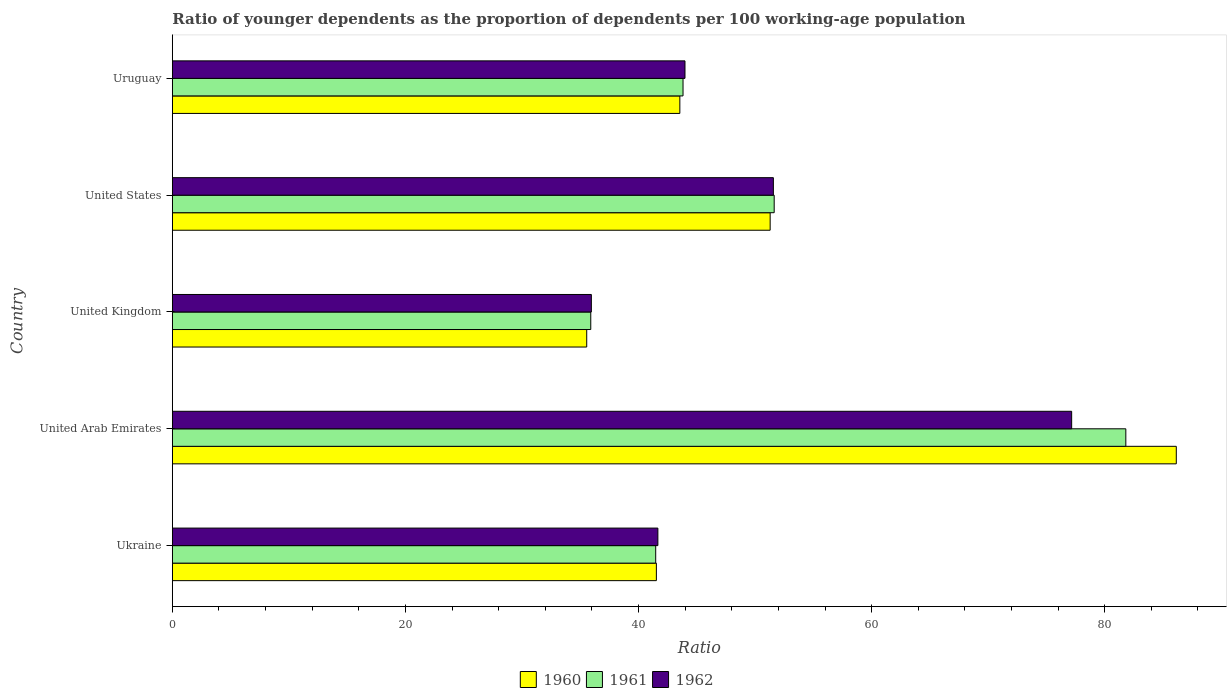How many different coloured bars are there?
Provide a succinct answer. 3. How many groups of bars are there?
Give a very brief answer. 5. Are the number of bars on each tick of the Y-axis equal?
Provide a short and direct response. Yes. How many bars are there on the 4th tick from the top?
Your response must be concise. 3. In how many cases, is the number of bars for a given country not equal to the number of legend labels?
Your answer should be compact. 0. What is the age dependency ratio(young) in 1962 in United States?
Ensure brevity in your answer.  51.57. Across all countries, what is the maximum age dependency ratio(young) in 1962?
Ensure brevity in your answer.  77.16. Across all countries, what is the minimum age dependency ratio(young) in 1962?
Ensure brevity in your answer.  35.95. In which country was the age dependency ratio(young) in 1962 maximum?
Provide a succinct answer. United Arab Emirates. In which country was the age dependency ratio(young) in 1960 minimum?
Make the answer very short. United Kingdom. What is the total age dependency ratio(young) in 1961 in the graph?
Give a very brief answer. 254.65. What is the difference between the age dependency ratio(young) in 1962 in United Kingdom and that in Uruguay?
Provide a succinct answer. -8.03. What is the difference between the age dependency ratio(young) in 1960 in United Kingdom and the age dependency ratio(young) in 1962 in Uruguay?
Provide a short and direct response. -8.43. What is the average age dependency ratio(young) in 1962 per country?
Provide a short and direct response. 50.07. What is the difference between the age dependency ratio(young) in 1961 and age dependency ratio(young) in 1960 in United Arab Emirates?
Your answer should be very brief. -4.33. What is the ratio of the age dependency ratio(young) in 1960 in Ukraine to that in United States?
Provide a short and direct response. 0.81. What is the difference between the highest and the second highest age dependency ratio(young) in 1961?
Make the answer very short. 30.17. What is the difference between the highest and the lowest age dependency ratio(young) in 1960?
Your answer should be compact. 50.59. In how many countries, is the age dependency ratio(young) in 1961 greater than the average age dependency ratio(young) in 1961 taken over all countries?
Make the answer very short. 2. Is the sum of the age dependency ratio(young) in 1961 in Ukraine and United Arab Emirates greater than the maximum age dependency ratio(young) in 1962 across all countries?
Keep it short and to the point. Yes. What does the 2nd bar from the top in United Arab Emirates represents?
Make the answer very short. 1961. Is it the case that in every country, the sum of the age dependency ratio(young) in 1962 and age dependency ratio(young) in 1961 is greater than the age dependency ratio(young) in 1960?
Your answer should be very brief. Yes. How many bars are there?
Ensure brevity in your answer.  15. Are the values on the major ticks of X-axis written in scientific E-notation?
Your answer should be compact. No. Does the graph contain any zero values?
Provide a short and direct response. No. Does the graph contain grids?
Make the answer very short. No. What is the title of the graph?
Offer a very short reply. Ratio of younger dependents as the proportion of dependents per 100 working-age population. What is the label or title of the X-axis?
Your response must be concise. Ratio. What is the Ratio of 1960 in Ukraine?
Ensure brevity in your answer.  41.53. What is the Ratio of 1961 in Ukraine?
Your answer should be compact. 41.47. What is the Ratio in 1962 in Ukraine?
Ensure brevity in your answer.  41.66. What is the Ratio in 1960 in United Arab Emirates?
Your answer should be very brief. 86.14. What is the Ratio in 1961 in United Arab Emirates?
Your answer should be compact. 81.81. What is the Ratio of 1962 in United Arab Emirates?
Make the answer very short. 77.16. What is the Ratio in 1960 in United Kingdom?
Your response must be concise. 35.55. What is the Ratio in 1961 in United Kingdom?
Make the answer very short. 35.9. What is the Ratio of 1962 in United Kingdom?
Your answer should be very brief. 35.95. What is the Ratio in 1960 in United States?
Provide a short and direct response. 51.29. What is the Ratio in 1961 in United States?
Your answer should be compact. 51.64. What is the Ratio in 1962 in United States?
Provide a short and direct response. 51.57. What is the Ratio in 1960 in Uruguay?
Provide a succinct answer. 43.54. What is the Ratio in 1961 in Uruguay?
Provide a short and direct response. 43.82. What is the Ratio in 1962 in Uruguay?
Provide a succinct answer. 43.99. Across all countries, what is the maximum Ratio of 1960?
Your answer should be compact. 86.14. Across all countries, what is the maximum Ratio of 1961?
Offer a terse response. 81.81. Across all countries, what is the maximum Ratio of 1962?
Give a very brief answer. 77.16. Across all countries, what is the minimum Ratio in 1960?
Provide a succinct answer. 35.55. Across all countries, what is the minimum Ratio of 1961?
Ensure brevity in your answer.  35.9. Across all countries, what is the minimum Ratio of 1962?
Provide a succinct answer. 35.95. What is the total Ratio in 1960 in the graph?
Offer a terse response. 258.07. What is the total Ratio of 1961 in the graph?
Your response must be concise. 254.65. What is the total Ratio of 1962 in the graph?
Give a very brief answer. 250.33. What is the difference between the Ratio in 1960 in Ukraine and that in United Arab Emirates?
Offer a terse response. -44.61. What is the difference between the Ratio in 1961 in Ukraine and that in United Arab Emirates?
Your answer should be very brief. -40.34. What is the difference between the Ratio of 1962 in Ukraine and that in United Arab Emirates?
Your answer should be compact. -35.5. What is the difference between the Ratio in 1960 in Ukraine and that in United Kingdom?
Offer a very short reply. 5.98. What is the difference between the Ratio in 1961 in Ukraine and that in United Kingdom?
Your answer should be compact. 5.57. What is the difference between the Ratio in 1962 in Ukraine and that in United Kingdom?
Make the answer very short. 5.71. What is the difference between the Ratio of 1960 in Ukraine and that in United States?
Provide a succinct answer. -9.76. What is the difference between the Ratio of 1961 in Ukraine and that in United States?
Provide a short and direct response. -10.17. What is the difference between the Ratio of 1962 in Ukraine and that in United States?
Give a very brief answer. -9.91. What is the difference between the Ratio of 1960 in Ukraine and that in Uruguay?
Offer a terse response. -2.01. What is the difference between the Ratio of 1961 in Ukraine and that in Uruguay?
Provide a succinct answer. -2.34. What is the difference between the Ratio of 1962 in Ukraine and that in Uruguay?
Make the answer very short. -2.33. What is the difference between the Ratio in 1960 in United Arab Emirates and that in United Kingdom?
Give a very brief answer. 50.59. What is the difference between the Ratio in 1961 in United Arab Emirates and that in United Kingdom?
Offer a very short reply. 45.91. What is the difference between the Ratio in 1962 in United Arab Emirates and that in United Kingdom?
Make the answer very short. 41.21. What is the difference between the Ratio of 1960 in United Arab Emirates and that in United States?
Ensure brevity in your answer.  34.85. What is the difference between the Ratio in 1961 in United Arab Emirates and that in United States?
Your answer should be compact. 30.17. What is the difference between the Ratio of 1962 in United Arab Emirates and that in United States?
Give a very brief answer. 25.59. What is the difference between the Ratio of 1960 in United Arab Emirates and that in Uruguay?
Your answer should be compact. 42.6. What is the difference between the Ratio in 1961 in United Arab Emirates and that in Uruguay?
Provide a short and direct response. 37.99. What is the difference between the Ratio of 1962 in United Arab Emirates and that in Uruguay?
Keep it short and to the point. 33.18. What is the difference between the Ratio in 1960 in United Kingdom and that in United States?
Ensure brevity in your answer.  -15.74. What is the difference between the Ratio in 1961 in United Kingdom and that in United States?
Provide a short and direct response. -15.74. What is the difference between the Ratio of 1962 in United Kingdom and that in United States?
Provide a short and direct response. -15.62. What is the difference between the Ratio of 1960 in United Kingdom and that in Uruguay?
Your answer should be compact. -7.99. What is the difference between the Ratio of 1961 in United Kingdom and that in Uruguay?
Your answer should be very brief. -7.92. What is the difference between the Ratio of 1962 in United Kingdom and that in Uruguay?
Your response must be concise. -8.03. What is the difference between the Ratio of 1960 in United States and that in Uruguay?
Provide a succinct answer. 7.75. What is the difference between the Ratio of 1961 in United States and that in Uruguay?
Offer a very short reply. 7.82. What is the difference between the Ratio in 1962 in United States and that in Uruguay?
Provide a succinct answer. 7.58. What is the difference between the Ratio of 1960 in Ukraine and the Ratio of 1961 in United Arab Emirates?
Provide a succinct answer. -40.28. What is the difference between the Ratio of 1960 in Ukraine and the Ratio of 1962 in United Arab Emirates?
Give a very brief answer. -35.63. What is the difference between the Ratio in 1961 in Ukraine and the Ratio in 1962 in United Arab Emirates?
Keep it short and to the point. -35.69. What is the difference between the Ratio in 1960 in Ukraine and the Ratio in 1961 in United Kingdom?
Your response must be concise. 5.63. What is the difference between the Ratio in 1960 in Ukraine and the Ratio in 1962 in United Kingdom?
Offer a terse response. 5.58. What is the difference between the Ratio of 1961 in Ukraine and the Ratio of 1962 in United Kingdom?
Give a very brief answer. 5.52. What is the difference between the Ratio of 1960 in Ukraine and the Ratio of 1961 in United States?
Make the answer very short. -10.11. What is the difference between the Ratio of 1960 in Ukraine and the Ratio of 1962 in United States?
Your response must be concise. -10.04. What is the difference between the Ratio of 1961 in Ukraine and the Ratio of 1962 in United States?
Provide a succinct answer. -10.1. What is the difference between the Ratio of 1960 in Ukraine and the Ratio of 1961 in Uruguay?
Provide a succinct answer. -2.29. What is the difference between the Ratio of 1960 in Ukraine and the Ratio of 1962 in Uruguay?
Ensure brevity in your answer.  -2.46. What is the difference between the Ratio in 1961 in Ukraine and the Ratio in 1962 in Uruguay?
Ensure brevity in your answer.  -2.51. What is the difference between the Ratio of 1960 in United Arab Emirates and the Ratio of 1961 in United Kingdom?
Keep it short and to the point. 50.24. What is the difference between the Ratio in 1960 in United Arab Emirates and the Ratio in 1962 in United Kingdom?
Provide a short and direct response. 50.19. What is the difference between the Ratio of 1961 in United Arab Emirates and the Ratio of 1962 in United Kingdom?
Ensure brevity in your answer.  45.86. What is the difference between the Ratio of 1960 in United Arab Emirates and the Ratio of 1961 in United States?
Provide a short and direct response. 34.5. What is the difference between the Ratio of 1960 in United Arab Emirates and the Ratio of 1962 in United States?
Make the answer very short. 34.57. What is the difference between the Ratio in 1961 in United Arab Emirates and the Ratio in 1962 in United States?
Your answer should be very brief. 30.24. What is the difference between the Ratio in 1960 in United Arab Emirates and the Ratio in 1961 in Uruguay?
Ensure brevity in your answer.  42.32. What is the difference between the Ratio of 1960 in United Arab Emirates and the Ratio of 1962 in Uruguay?
Your response must be concise. 42.16. What is the difference between the Ratio of 1961 in United Arab Emirates and the Ratio of 1962 in Uruguay?
Your answer should be very brief. 37.83. What is the difference between the Ratio in 1960 in United Kingdom and the Ratio in 1961 in United States?
Give a very brief answer. -16.09. What is the difference between the Ratio of 1960 in United Kingdom and the Ratio of 1962 in United States?
Keep it short and to the point. -16.02. What is the difference between the Ratio of 1961 in United Kingdom and the Ratio of 1962 in United States?
Your answer should be compact. -15.67. What is the difference between the Ratio in 1960 in United Kingdom and the Ratio in 1961 in Uruguay?
Keep it short and to the point. -8.26. What is the difference between the Ratio in 1960 in United Kingdom and the Ratio in 1962 in Uruguay?
Provide a short and direct response. -8.43. What is the difference between the Ratio in 1961 in United Kingdom and the Ratio in 1962 in Uruguay?
Provide a succinct answer. -8.08. What is the difference between the Ratio of 1960 in United States and the Ratio of 1961 in Uruguay?
Offer a very short reply. 7.48. What is the difference between the Ratio in 1960 in United States and the Ratio in 1962 in Uruguay?
Keep it short and to the point. 7.31. What is the difference between the Ratio of 1961 in United States and the Ratio of 1962 in Uruguay?
Your response must be concise. 7.65. What is the average Ratio in 1960 per country?
Your answer should be very brief. 51.61. What is the average Ratio of 1961 per country?
Give a very brief answer. 50.93. What is the average Ratio of 1962 per country?
Make the answer very short. 50.07. What is the difference between the Ratio in 1960 and Ratio in 1961 in Ukraine?
Provide a succinct answer. 0.06. What is the difference between the Ratio in 1960 and Ratio in 1962 in Ukraine?
Provide a short and direct response. -0.13. What is the difference between the Ratio of 1961 and Ratio of 1962 in Ukraine?
Offer a very short reply. -0.19. What is the difference between the Ratio of 1960 and Ratio of 1961 in United Arab Emirates?
Offer a very short reply. 4.33. What is the difference between the Ratio of 1960 and Ratio of 1962 in United Arab Emirates?
Your answer should be compact. 8.98. What is the difference between the Ratio in 1961 and Ratio in 1962 in United Arab Emirates?
Your answer should be very brief. 4.65. What is the difference between the Ratio in 1960 and Ratio in 1961 in United Kingdom?
Ensure brevity in your answer.  -0.35. What is the difference between the Ratio of 1960 and Ratio of 1962 in United Kingdom?
Offer a terse response. -0.4. What is the difference between the Ratio of 1961 and Ratio of 1962 in United Kingdom?
Offer a very short reply. -0.05. What is the difference between the Ratio in 1960 and Ratio in 1961 in United States?
Make the answer very short. -0.35. What is the difference between the Ratio of 1960 and Ratio of 1962 in United States?
Give a very brief answer. -0.28. What is the difference between the Ratio in 1961 and Ratio in 1962 in United States?
Ensure brevity in your answer.  0.07. What is the difference between the Ratio of 1960 and Ratio of 1961 in Uruguay?
Keep it short and to the point. -0.27. What is the difference between the Ratio in 1960 and Ratio in 1962 in Uruguay?
Keep it short and to the point. -0.44. What is the difference between the Ratio of 1961 and Ratio of 1962 in Uruguay?
Ensure brevity in your answer.  -0.17. What is the ratio of the Ratio of 1960 in Ukraine to that in United Arab Emirates?
Your answer should be compact. 0.48. What is the ratio of the Ratio of 1961 in Ukraine to that in United Arab Emirates?
Your answer should be compact. 0.51. What is the ratio of the Ratio in 1962 in Ukraine to that in United Arab Emirates?
Provide a short and direct response. 0.54. What is the ratio of the Ratio in 1960 in Ukraine to that in United Kingdom?
Your answer should be very brief. 1.17. What is the ratio of the Ratio of 1961 in Ukraine to that in United Kingdom?
Make the answer very short. 1.16. What is the ratio of the Ratio of 1962 in Ukraine to that in United Kingdom?
Keep it short and to the point. 1.16. What is the ratio of the Ratio of 1960 in Ukraine to that in United States?
Keep it short and to the point. 0.81. What is the ratio of the Ratio in 1961 in Ukraine to that in United States?
Provide a succinct answer. 0.8. What is the ratio of the Ratio of 1962 in Ukraine to that in United States?
Give a very brief answer. 0.81. What is the ratio of the Ratio of 1960 in Ukraine to that in Uruguay?
Your answer should be very brief. 0.95. What is the ratio of the Ratio in 1961 in Ukraine to that in Uruguay?
Offer a very short reply. 0.95. What is the ratio of the Ratio of 1962 in Ukraine to that in Uruguay?
Provide a succinct answer. 0.95. What is the ratio of the Ratio of 1960 in United Arab Emirates to that in United Kingdom?
Provide a succinct answer. 2.42. What is the ratio of the Ratio of 1961 in United Arab Emirates to that in United Kingdom?
Your response must be concise. 2.28. What is the ratio of the Ratio in 1962 in United Arab Emirates to that in United Kingdom?
Provide a short and direct response. 2.15. What is the ratio of the Ratio in 1960 in United Arab Emirates to that in United States?
Provide a succinct answer. 1.68. What is the ratio of the Ratio of 1961 in United Arab Emirates to that in United States?
Provide a short and direct response. 1.58. What is the ratio of the Ratio of 1962 in United Arab Emirates to that in United States?
Give a very brief answer. 1.5. What is the ratio of the Ratio of 1960 in United Arab Emirates to that in Uruguay?
Your answer should be very brief. 1.98. What is the ratio of the Ratio of 1961 in United Arab Emirates to that in Uruguay?
Give a very brief answer. 1.87. What is the ratio of the Ratio of 1962 in United Arab Emirates to that in Uruguay?
Offer a terse response. 1.75. What is the ratio of the Ratio in 1960 in United Kingdom to that in United States?
Your response must be concise. 0.69. What is the ratio of the Ratio in 1961 in United Kingdom to that in United States?
Provide a short and direct response. 0.7. What is the ratio of the Ratio in 1962 in United Kingdom to that in United States?
Your answer should be compact. 0.7. What is the ratio of the Ratio of 1960 in United Kingdom to that in Uruguay?
Give a very brief answer. 0.82. What is the ratio of the Ratio of 1961 in United Kingdom to that in Uruguay?
Give a very brief answer. 0.82. What is the ratio of the Ratio in 1962 in United Kingdom to that in Uruguay?
Offer a very short reply. 0.82. What is the ratio of the Ratio of 1960 in United States to that in Uruguay?
Provide a succinct answer. 1.18. What is the ratio of the Ratio in 1961 in United States to that in Uruguay?
Offer a very short reply. 1.18. What is the ratio of the Ratio of 1962 in United States to that in Uruguay?
Your response must be concise. 1.17. What is the difference between the highest and the second highest Ratio of 1960?
Provide a short and direct response. 34.85. What is the difference between the highest and the second highest Ratio in 1961?
Give a very brief answer. 30.17. What is the difference between the highest and the second highest Ratio in 1962?
Give a very brief answer. 25.59. What is the difference between the highest and the lowest Ratio of 1960?
Your answer should be compact. 50.59. What is the difference between the highest and the lowest Ratio of 1961?
Offer a very short reply. 45.91. What is the difference between the highest and the lowest Ratio of 1962?
Offer a terse response. 41.21. 